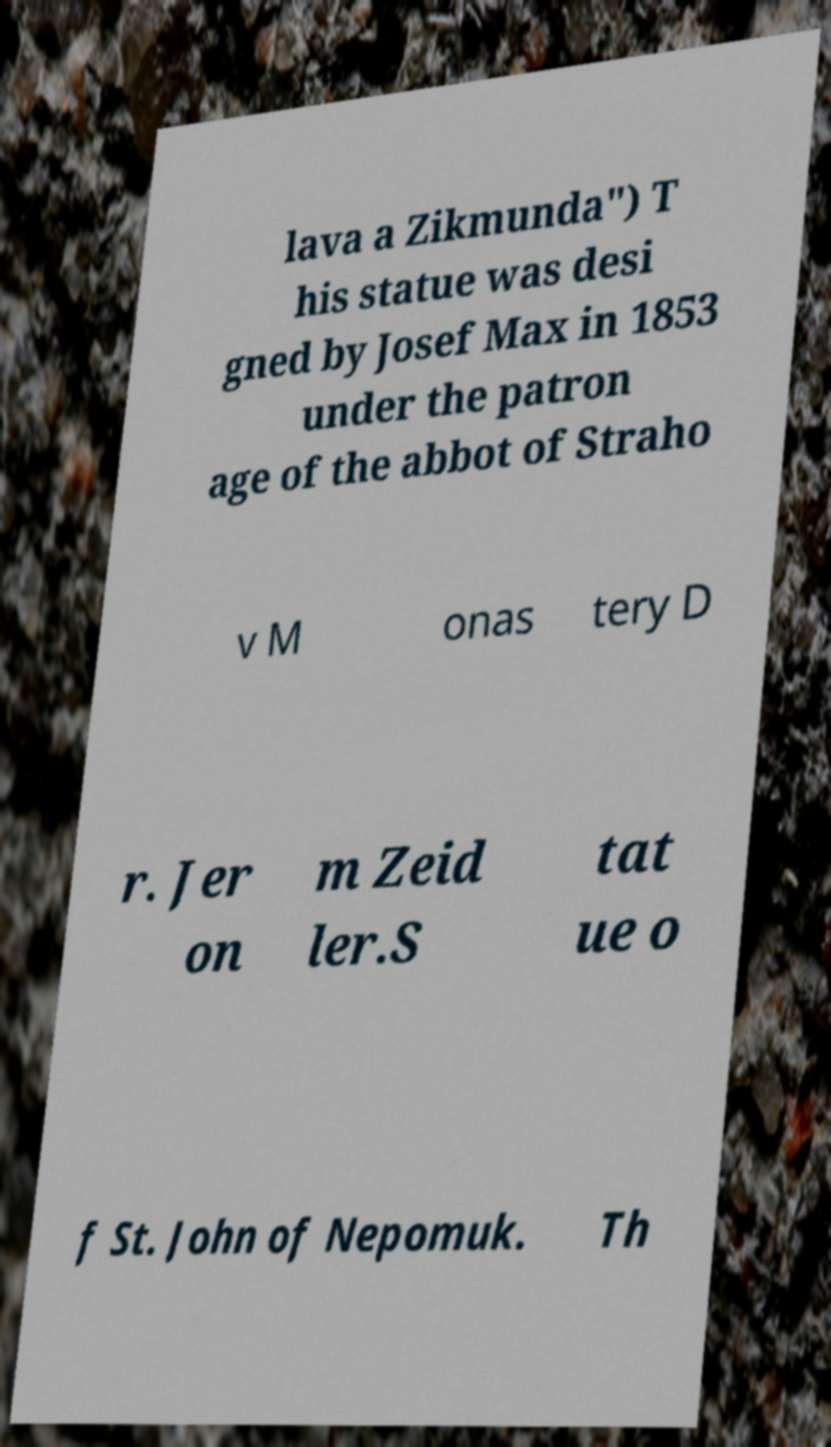I need the written content from this picture converted into text. Can you do that? lava a Zikmunda") T his statue was desi gned by Josef Max in 1853 under the patron age of the abbot of Straho v M onas tery D r. Jer on m Zeid ler.S tat ue o f St. John of Nepomuk. Th 